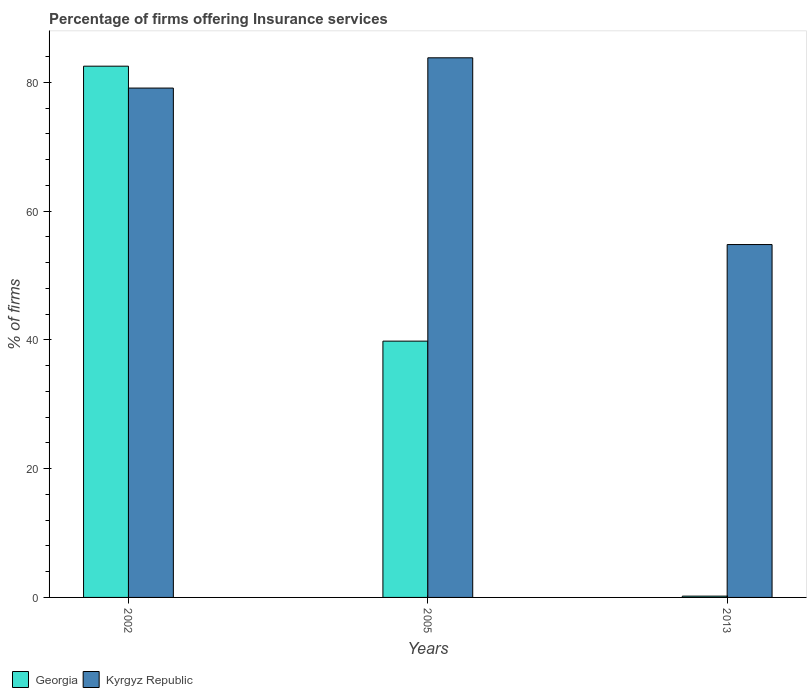Are the number of bars per tick equal to the number of legend labels?
Make the answer very short. Yes. Are the number of bars on each tick of the X-axis equal?
Your response must be concise. Yes. How many bars are there on the 1st tick from the left?
Provide a succinct answer. 2. What is the label of the 3rd group of bars from the left?
Ensure brevity in your answer.  2013. In how many cases, is the number of bars for a given year not equal to the number of legend labels?
Your answer should be compact. 0. What is the percentage of firms offering insurance services in Kyrgyz Republic in 2013?
Your response must be concise. 54.8. Across all years, what is the maximum percentage of firms offering insurance services in Kyrgyz Republic?
Offer a very short reply. 83.8. Across all years, what is the minimum percentage of firms offering insurance services in Georgia?
Ensure brevity in your answer.  0.2. In which year was the percentage of firms offering insurance services in Kyrgyz Republic maximum?
Keep it short and to the point. 2005. In which year was the percentage of firms offering insurance services in Kyrgyz Republic minimum?
Your answer should be compact. 2013. What is the total percentage of firms offering insurance services in Kyrgyz Republic in the graph?
Make the answer very short. 217.7. What is the difference between the percentage of firms offering insurance services in Georgia in 2002 and that in 2013?
Ensure brevity in your answer.  82.3. What is the difference between the percentage of firms offering insurance services in Georgia in 2002 and the percentage of firms offering insurance services in Kyrgyz Republic in 2013?
Offer a terse response. 27.7. What is the average percentage of firms offering insurance services in Kyrgyz Republic per year?
Offer a very short reply. 72.57. In the year 2005, what is the difference between the percentage of firms offering insurance services in Kyrgyz Republic and percentage of firms offering insurance services in Georgia?
Offer a very short reply. 44. What is the ratio of the percentage of firms offering insurance services in Georgia in 2005 to that in 2013?
Provide a short and direct response. 199. Is the difference between the percentage of firms offering insurance services in Kyrgyz Republic in 2005 and 2013 greater than the difference between the percentage of firms offering insurance services in Georgia in 2005 and 2013?
Offer a terse response. No. What is the difference between the highest and the second highest percentage of firms offering insurance services in Georgia?
Your answer should be compact. 42.7. What is the difference between the highest and the lowest percentage of firms offering insurance services in Kyrgyz Republic?
Your answer should be compact. 29. Is the sum of the percentage of firms offering insurance services in Kyrgyz Republic in 2002 and 2005 greater than the maximum percentage of firms offering insurance services in Georgia across all years?
Give a very brief answer. Yes. What does the 2nd bar from the left in 2013 represents?
Offer a very short reply. Kyrgyz Republic. What does the 2nd bar from the right in 2005 represents?
Your answer should be very brief. Georgia. How many years are there in the graph?
Your response must be concise. 3. What is the difference between two consecutive major ticks on the Y-axis?
Provide a short and direct response. 20. How many legend labels are there?
Ensure brevity in your answer.  2. How are the legend labels stacked?
Offer a very short reply. Horizontal. What is the title of the graph?
Keep it short and to the point. Percentage of firms offering Insurance services. What is the label or title of the Y-axis?
Offer a terse response. % of firms. What is the % of firms in Georgia in 2002?
Provide a short and direct response. 82.5. What is the % of firms of Kyrgyz Republic in 2002?
Make the answer very short. 79.1. What is the % of firms in Georgia in 2005?
Make the answer very short. 39.8. What is the % of firms of Kyrgyz Republic in 2005?
Offer a terse response. 83.8. What is the % of firms of Kyrgyz Republic in 2013?
Ensure brevity in your answer.  54.8. Across all years, what is the maximum % of firms of Georgia?
Give a very brief answer. 82.5. Across all years, what is the maximum % of firms of Kyrgyz Republic?
Make the answer very short. 83.8. Across all years, what is the minimum % of firms of Georgia?
Provide a succinct answer. 0.2. Across all years, what is the minimum % of firms in Kyrgyz Republic?
Make the answer very short. 54.8. What is the total % of firms of Georgia in the graph?
Offer a very short reply. 122.5. What is the total % of firms of Kyrgyz Republic in the graph?
Offer a very short reply. 217.7. What is the difference between the % of firms of Georgia in 2002 and that in 2005?
Offer a very short reply. 42.7. What is the difference between the % of firms in Kyrgyz Republic in 2002 and that in 2005?
Provide a short and direct response. -4.7. What is the difference between the % of firms of Georgia in 2002 and that in 2013?
Offer a terse response. 82.3. What is the difference between the % of firms of Kyrgyz Republic in 2002 and that in 2013?
Provide a succinct answer. 24.3. What is the difference between the % of firms of Georgia in 2005 and that in 2013?
Make the answer very short. 39.6. What is the difference between the % of firms in Georgia in 2002 and the % of firms in Kyrgyz Republic in 2005?
Give a very brief answer. -1.3. What is the difference between the % of firms of Georgia in 2002 and the % of firms of Kyrgyz Republic in 2013?
Make the answer very short. 27.7. What is the difference between the % of firms in Georgia in 2005 and the % of firms in Kyrgyz Republic in 2013?
Your answer should be compact. -15. What is the average % of firms of Georgia per year?
Provide a succinct answer. 40.83. What is the average % of firms in Kyrgyz Republic per year?
Make the answer very short. 72.57. In the year 2005, what is the difference between the % of firms of Georgia and % of firms of Kyrgyz Republic?
Make the answer very short. -44. In the year 2013, what is the difference between the % of firms of Georgia and % of firms of Kyrgyz Republic?
Offer a terse response. -54.6. What is the ratio of the % of firms of Georgia in 2002 to that in 2005?
Your answer should be very brief. 2.07. What is the ratio of the % of firms in Kyrgyz Republic in 2002 to that in 2005?
Keep it short and to the point. 0.94. What is the ratio of the % of firms of Georgia in 2002 to that in 2013?
Your answer should be very brief. 412.5. What is the ratio of the % of firms in Kyrgyz Republic in 2002 to that in 2013?
Offer a very short reply. 1.44. What is the ratio of the % of firms of Georgia in 2005 to that in 2013?
Offer a very short reply. 199. What is the ratio of the % of firms of Kyrgyz Republic in 2005 to that in 2013?
Keep it short and to the point. 1.53. What is the difference between the highest and the second highest % of firms of Georgia?
Your answer should be very brief. 42.7. What is the difference between the highest and the lowest % of firms in Georgia?
Offer a terse response. 82.3. 